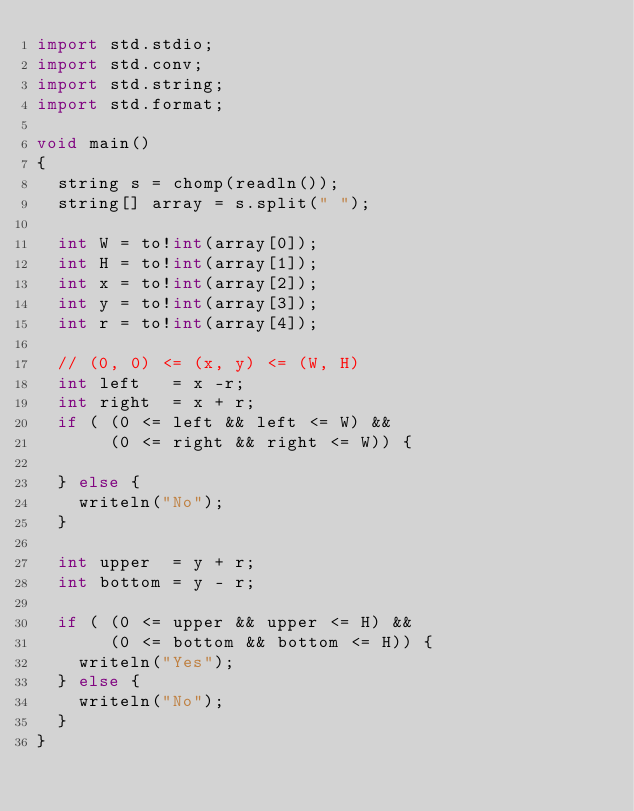Convert code to text. <code><loc_0><loc_0><loc_500><loc_500><_D_>import std.stdio;
import std.conv;
import std.string;
import std.format;
 
void main()
{
  string s = chomp(readln());
  string[] array = s.split(" ");
 
  int W = to!int(array[0]);
  int H = to!int(array[1]);
  int x = to!int(array[2]);
  int y = to!int(array[3]);
  int r = to!int(array[4]);
 
  // (0, 0) <= (x, y) <= (W, H)
  int left   = x -r;
  int right  = x + r;
  if ( (0 <= left && left <= W) &&
       (0 <= right && right <= W)) {
 
  } else {
    writeln("No");
  }
 
  int upper  = y + r;
  int bottom = y - r;
 
  if ( (0 <= upper && upper <= H) &&
       (0 <= bottom && bottom <= H)) {
    writeln("Yes");
  } else {
    writeln("No");
  }
}</code> 